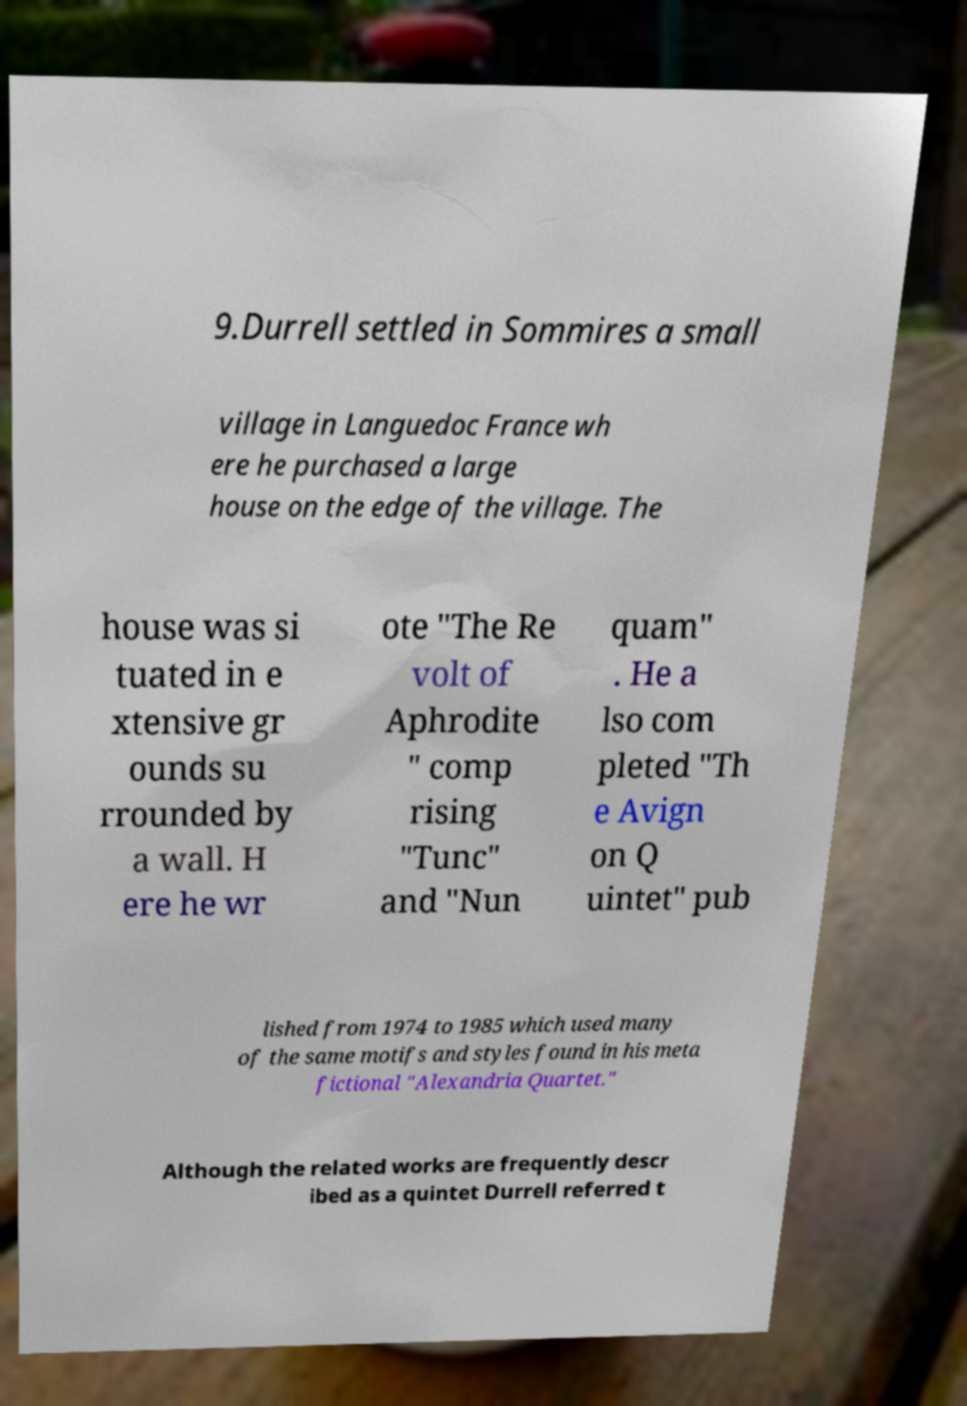Can you accurately transcribe the text from the provided image for me? 9.Durrell settled in Sommires a small village in Languedoc France wh ere he purchased a large house on the edge of the village. The house was si tuated in e xtensive gr ounds su rrounded by a wall. H ere he wr ote "The Re volt of Aphrodite " comp rising "Tunc" and "Nun quam" . He a lso com pleted "Th e Avign on Q uintet" pub lished from 1974 to 1985 which used many of the same motifs and styles found in his meta fictional "Alexandria Quartet." Although the related works are frequently descr ibed as a quintet Durrell referred t 